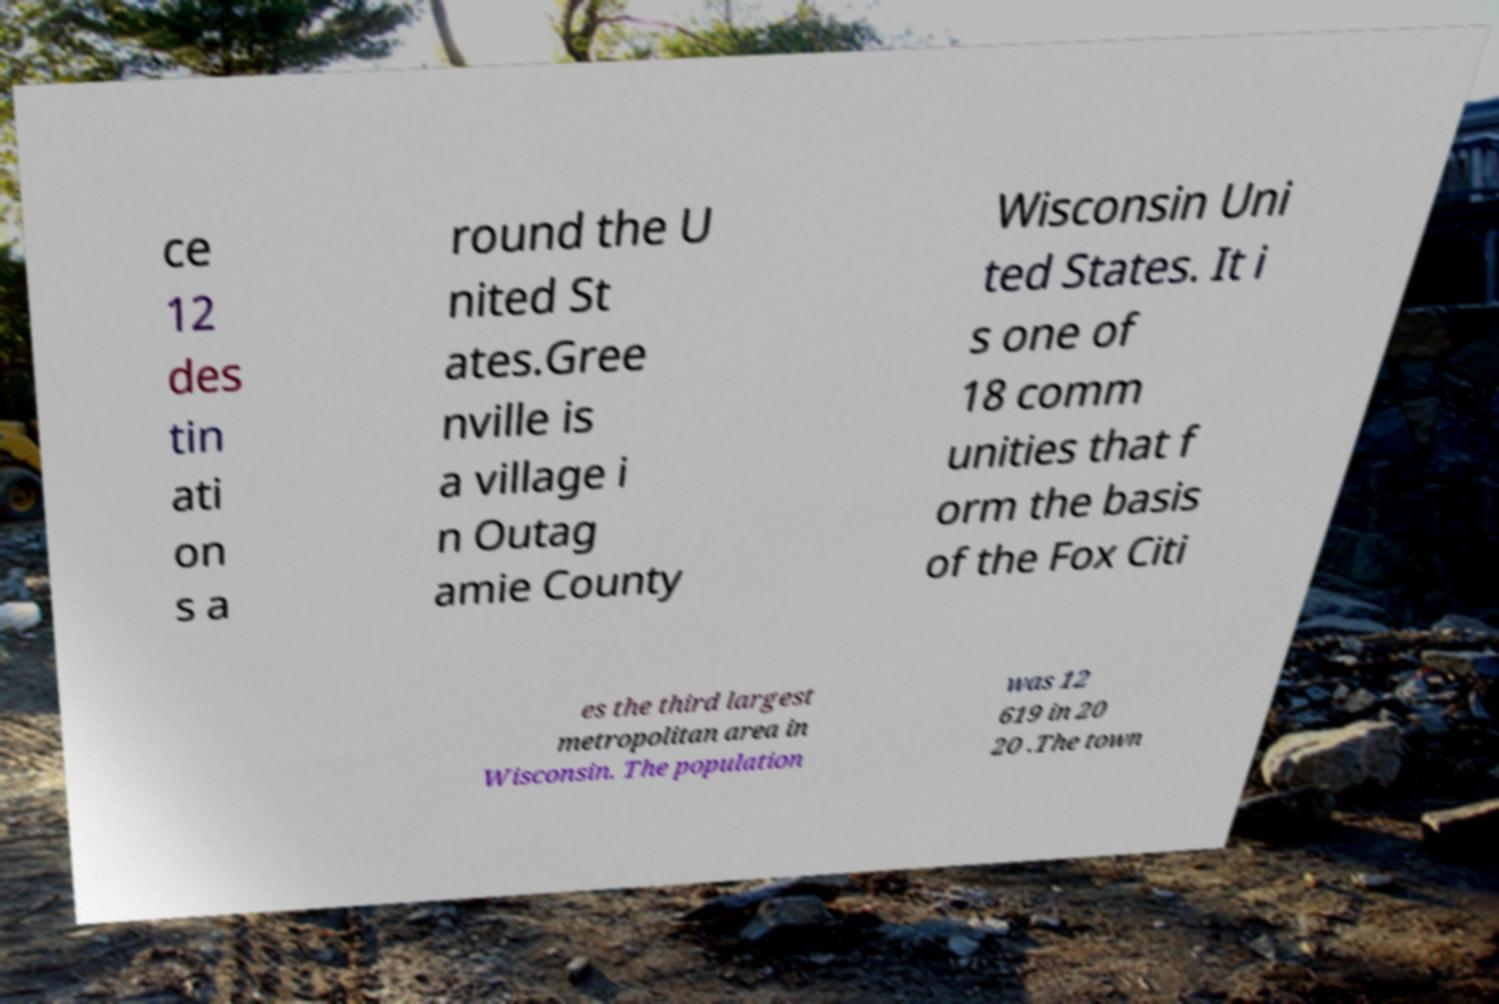Could you extract and type out the text from this image? ce 12 des tin ati on s a round the U nited St ates.Gree nville is a village i n Outag amie County Wisconsin Uni ted States. It i s one of 18 comm unities that f orm the basis of the Fox Citi es the third largest metropolitan area in Wisconsin. The population was 12 619 in 20 20 .The town 